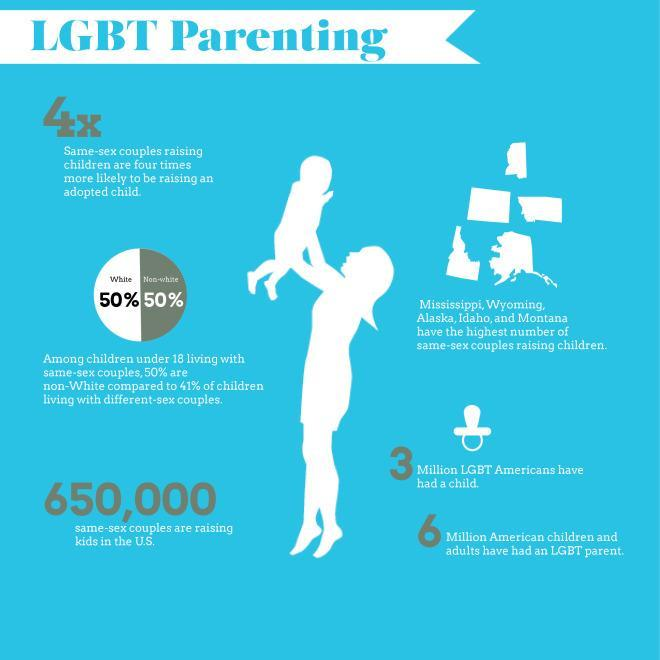Among children under 18 living with the same-sex couples, what percentage of them are whites?
Answer the question with a short phrase. 50% What is the population of American children and adults who have an LGBT parent? 6 Million What is the number of same-sex couples who are raising kids in the U.S.? 650,000 What is the population of LGBT Americans who have a child? 3 Million 